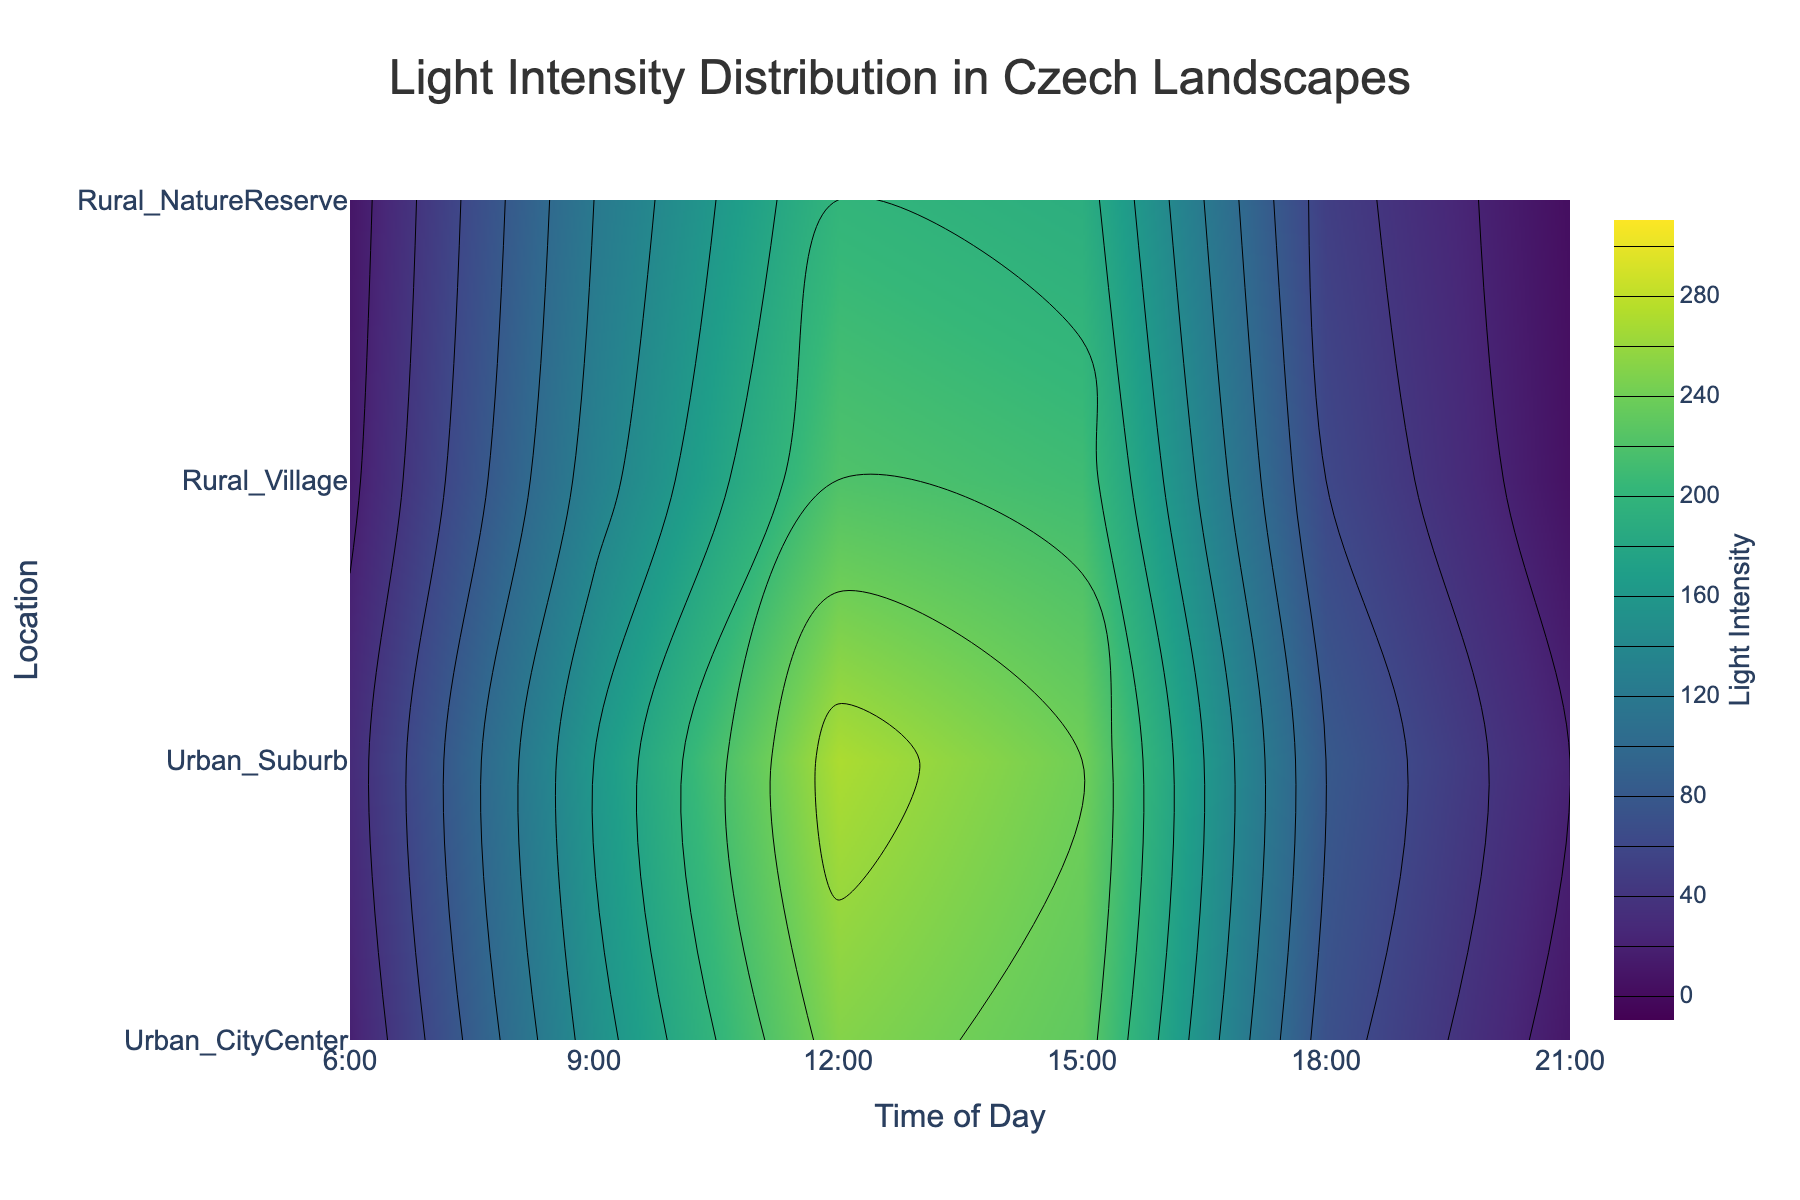What is the highest light intensity recorded in Urban City Center? The plot displays the contours for light intensity values across different times of day and locations. In the Urban City Center, the highest light intensity appears to be around noon.
Answer: 250 What time of day has the lowest light intensity in the Rural Nature Reserve? By observing the contours in the plot, the lowest light intensity for Rural Nature Reserve is at 21:00.
Answer: 2 Compare the light intensities at 15:00 between the Urban Suburb and the Rural Village. Which one is higher? To compare, locate the 15:00 line for both Urban Suburb and Rural Village. The contours for the Urban Suburb are higher than Rural Village at this time.
Answer: Urban Suburb What is the average light intensity at 18:00 across all locations? Sum the light intensities at 18:00 for all four locations: 70 (Urban City Center) + 80 (Urban Suburb) + 60 (Rural Village) + 50 (Rural Nature Reserve) = 260. There are 4 locations, so the average is 260/4.
Answer: 65 Are there any times of day where light intensity is exactly 200 in any of the locations? Look at the contour lines that represent the value 200 and check where they intersect the times of day. The lines intersect around 12:00 and slightly around 15:00 in different locations.
Answer: Yes Do both Urban locations have higher light intensities at 12:00 compared to 6:00? Compare the light intensities at 12:00 and 6:00 in both Urban City Center and Urban Suburb. At 12:00, it's 250 and 270, and at 6:00, it's 20 and 30, respectively. Both are higher at 12:00.
Answer: Yes Which location has the smallest increase in light intensity from 6:00 to 9:00? Calculate the difference from 6:00 to 9:00 for each location and compare: 
Urban City Center (150-20 = 130), Urban Suburb (160-30 = 130), Rural Village (130-15 = 115), Rural Nature Reserve (120-10 = 110). The smallest increase is Rural Nature Reserve.
Answer: Rural Nature Reserve What is the general trend in light intensity from 6:00 to 21:00 in the Urban City Center? By observing the contours, the light intensity starts low, peaks around noon, slightly decreases by 18:00, and drops significantly by 21:00.
Answer: Peak at noon At 9:00, does the Rural Village have a higher light intensity than the Urban City Center? Compare the light intensities at 9:00 for Rural Village and Urban City Center. The Rural Village is 130 and Urban City Center is 150. Urban City Center is higher.
Answer: No 